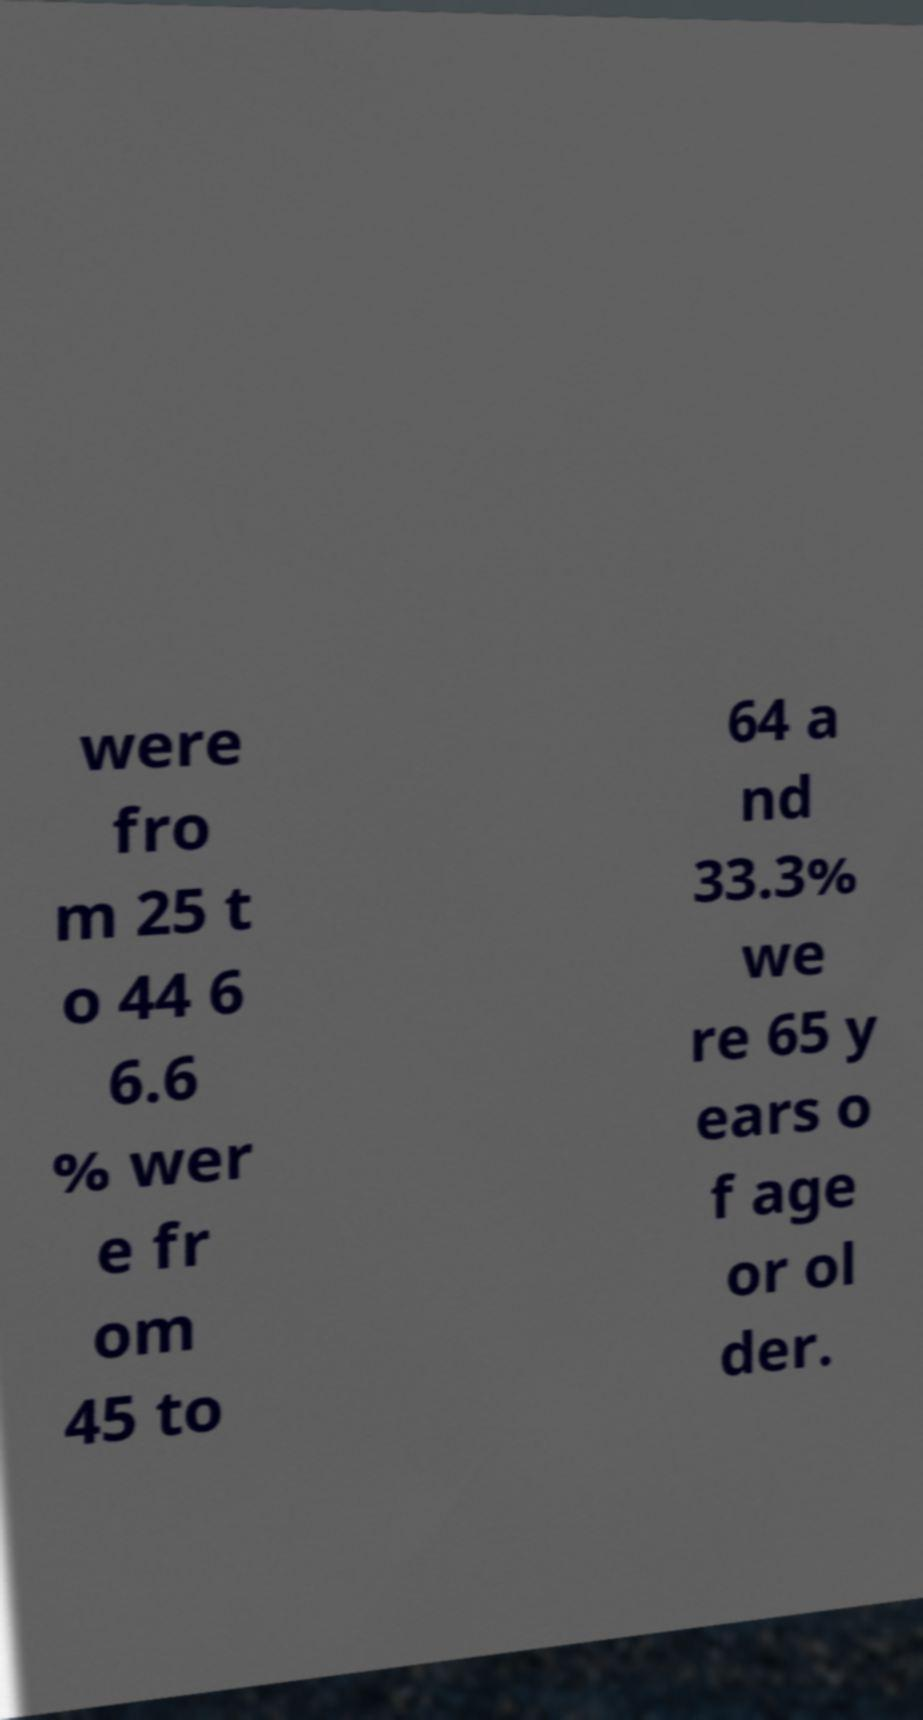I need the written content from this picture converted into text. Can you do that? were fro m 25 t o 44 6 6.6 % wer e fr om 45 to 64 a nd 33.3% we re 65 y ears o f age or ol der. 